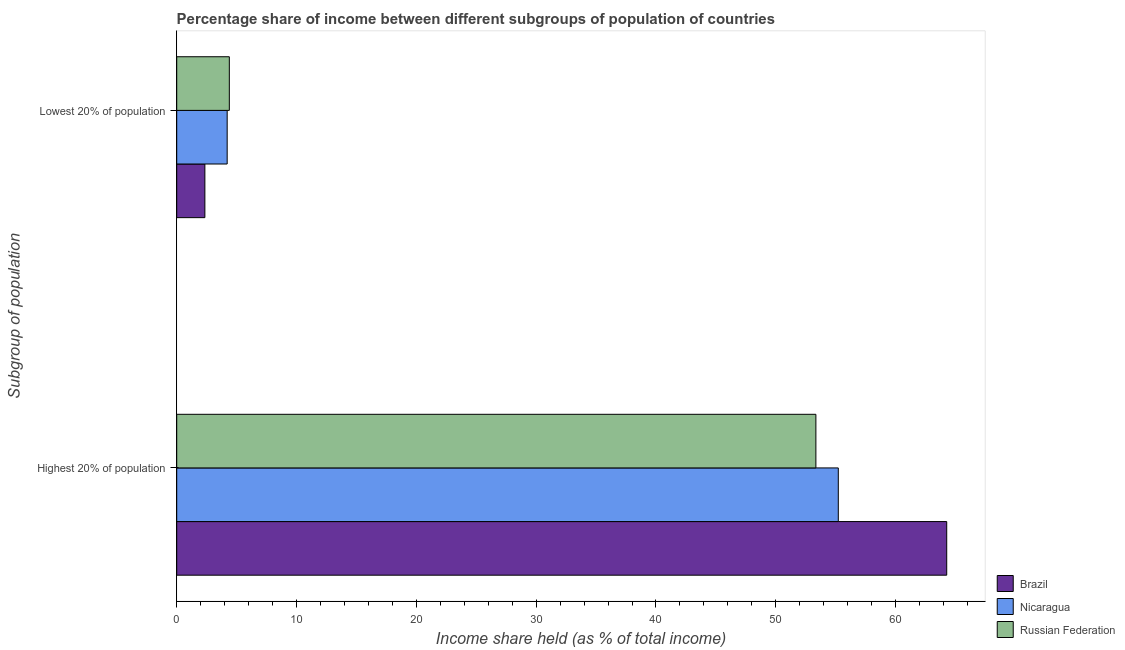Are the number of bars per tick equal to the number of legend labels?
Ensure brevity in your answer.  Yes. Are the number of bars on each tick of the Y-axis equal?
Your answer should be very brief. Yes. How many bars are there on the 2nd tick from the top?
Offer a very short reply. 3. How many bars are there on the 2nd tick from the bottom?
Give a very brief answer. 3. What is the label of the 2nd group of bars from the top?
Make the answer very short. Highest 20% of population. What is the income share held by highest 20% of the population in Nicaragua?
Your answer should be very brief. 55.22. Across all countries, what is the maximum income share held by highest 20% of the population?
Offer a terse response. 64.27. Across all countries, what is the minimum income share held by lowest 20% of the population?
Ensure brevity in your answer.  2.35. In which country was the income share held by lowest 20% of the population minimum?
Your answer should be very brief. Brazil. What is the total income share held by highest 20% of the population in the graph?
Ensure brevity in your answer.  172.84. What is the difference between the income share held by highest 20% of the population in Nicaragua and that in Brazil?
Offer a terse response. -9.05. What is the difference between the income share held by lowest 20% of the population in Russian Federation and the income share held by highest 20% of the population in Nicaragua?
Your response must be concise. -50.83. What is the average income share held by lowest 20% of the population per country?
Provide a succinct answer. 3.65. What is the difference between the income share held by highest 20% of the population and income share held by lowest 20% of the population in Brazil?
Your response must be concise. 61.92. What is the ratio of the income share held by highest 20% of the population in Russian Federation to that in Nicaragua?
Ensure brevity in your answer.  0.97. Is the income share held by highest 20% of the population in Brazil less than that in Russian Federation?
Your answer should be very brief. No. What does the 1st bar from the top in Lowest 20% of population represents?
Your answer should be compact. Russian Federation. What does the 3rd bar from the bottom in Lowest 20% of population represents?
Give a very brief answer. Russian Federation. Are all the bars in the graph horizontal?
Provide a succinct answer. Yes. Are the values on the major ticks of X-axis written in scientific E-notation?
Make the answer very short. No. Does the graph contain any zero values?
Provide a succinct answer. No. Does the graph contain grids?
Offer a very short reply. No. Where does the legend appear in the graph?
Offer a terse response. Bottom right. How many legend labels are there?
Offer a very short reply. 3. What is the title of the graph?
Offer a terse response. Percentage share of income between different subgroups of population of countries. Does "Angola" appear as one of the legend labels in the graph?
Ensure brevity in your answer.  No. What is the label or title of the X-axis?
Provide a short and direct response. Income share held (as % of total income). What is the label or title of the Y-axis?
Offer a very short reply. Subgroup of population. What is the Income share held (as % of total income) in Brazil in Highest 20% of population?
Offer a very short reply. 64.27. What is the Income share held (as % of total income) in Nicaragua in Highest 20% of population?
Give a very brief answer. 55.22. What is the Income share held (as % of total income) in Russian Federation in Highest 20% of population?
Make the answer very short. 53.35. What is the Income share held (as % of total income) of Brazil in Lowest 20% of population?
Make the answer very short. 2.35. What is the Income share held (as % of total income) of Nicaragua in Lowest 20% of population?
Offer a very short reply. 4.21. What is the Income share held (as % of total income) in Russian Federation in Lowest 20% of population?
Your answer should be very brief. 4.39. Across all Subgroup of population, what is the maximum Income share held (as % of total income) in Brazil?
Offer a very short reply. 64.27. Across all Subgroup of population, what is the maximum Income share held (as % of total income) in Nicaragua?
Your answer should be very brief. 55.22. Across all Subgroup of population, what is the maximum Income share held (as % of total income) of Russian Federation?
Keep it short and to the point. 53.35. Across all Subgroup of population, what is the minimum Income share held (as % of total income) of Brazil?
Ensure brevity in your answer.  2.35. Across all Subgroup of population, what is the minimum Income share held (as % of total income) of Nicaragua?
Offer a terse response. 4.21. Across all Subgroup of population, what is the minimum Income share held (as % of total income) of Russian Federation?
Provide a short and direct response. 4.39. What is the total Income share held (as % of total income) of Brazil in the graph?
Keep it short and to the point. 66.62. What is the total Income share held (as % of total income) in Nicaragua in the graph?
Provide a short and direct response. 59.43. What is the total Income share held (as % of total income) of Russian Federation in the graph?
Keep it short and to the point. 57.74. What is the difference between the Income share held (as % of total income) of Brazil in Highest 20% of population and that in Lowest 20% of population?
Offer a very short reply. 61.92. What is the difference between the Income share held (as % of total income) of Nicaragua in Highest 20% of population and that in Lowest 20% of population?
Provide a succinct answer. 51.01. What is the difference between the Income share held (as % of total income) of Russian Federation in Highest 20% of population and that in Lowest 20% of population?
Offer a very short reply. 48.96. What is the difference between the Income share held (as % of total income) in Brazil in Highest 20% of population and the Income share held (as % of total income) in Nicaragua in Lowest 20% of population?
Offer a very short reply. 60.06. What is the difference between the Income share held (as % of total income) of Brazil in Highest 20% of population and the Income share held (as % of total income) of Russian Federation in Lowest 20% of population?
Your answer should be compact. 59.88. What is the difference between the Income share held (as % of total income) in Nicaragua in Highest 20% of population and the Income share held (as % of total income) in Russian Federation in Lowest 20% of population?
Give a very brief answer. 50.83. What is the average Income share held (as % of total income) in Brazil per Subgroup of population?
Provide a succinct answer. 33.31. What is the average Income share held (as % of total income) of Nicaragua per Subgroup of population?
Keep it short and to the point. 29.71. What is the average Income share held (as % of total income) in Russian Federation per Subgroup of population?
Ensure brevity in your answer.  28.87. What is the difference between the Income share held (as % of total income) in Brazil and Income share held (as % of total income) in Nicaragua in Highest 20% of population?
Offer a very short reply. 9.05. What is the difference between the Income share held (as % of total income) in Brazil and Income share held (as % of total income) in Russian Federation in Highest 20% of population?
Make the answer very short. 10.92. What is the difference between the Income share held (as % of total income) of Nicaragua and Income share held (as % of total income) of Russian Federation in Highest 20% of population?
Keep it short and to the point. 1.87. What is the difference between the Income share held (as % of total income) in Brazil and Income share held (as % of total income) in Nicaragua in Lowest 20% of population?
Your answer should be very brief. -1.86. What is the difference between the Income share held (as % of total income) of Brazil and Income share held (as % of total income) of Russian Federation in Lowest 20% of population?
Your response must be concise. -2.04. What is the difference between the Income share held (as % of total income) of Nicaragua and Income share held (as % of total income) of Russian Federation in Lowest 20% of population?
Give a very brief answer. -0.18. What is the ratio of the Income share held (as % of total income) of Brazil in Highest 20% of population to that in Lowest 20% of population?
Offer a very short reply. 27.35. What is the ratio of the Income share held (as % of total income) of Nicaragua in Highest 20% of population to that in Lowest 20% of population?
Offer a terse response. 13.12. What is the ratio of the Income share held (as % of total income) of Russian Federation in Highest 20% of population to that in Lowest 20% of population?
Keep it short and to the point. 12.15. What is the difference between the highest and the second highest Income share held (as % of total income) of Brazil?
Give a very brief answer. 61.92. What is the difference between the highest and the second highest Income share held (as % of total income) in Nicaragua?
Ensure brevity in your answer.  51.01. What is the difference between the highest and the second highest Income share held (as % of total income) of Russian Federation?
Offer a very short reply. 48.96. What is the difference between the highest and the lowest Income share held (as % of total income) of Brazil?
Your answer should be compact. 61.92. What is the difference between the highest and the lowest Income share held (as % of total income) of Nicaragua?
Your answer should be compact. 51.01. What is the difference between the highest and the lowest Income share held (as % of total income) in Russian Federation?
Provide a succinct answer. 48.96. 